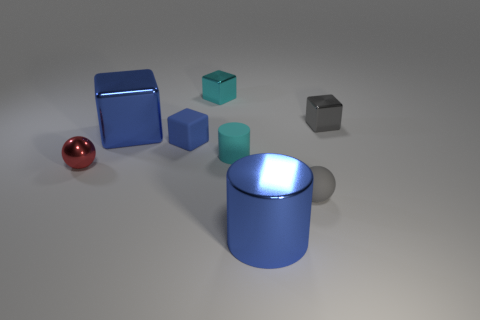The small metallic object that is the same color as the small cylinder is what shape?
Your answer should be compact. Cube. There is a rubber cube that is the same color as the large cylinder; what size is it?
Offer a terse response. Small. Is there a large cylinder made of the same material as the small blue thing?
Offer a terse response. No. There is a tiny metal object that is behind the small red ball and on the left side of the tiny cyan cylinder; what is its shape?
Make the answer very short. Cube. How many other objects are the same shape as the blue matte thing?
Your response must be concise. 3. The gray ball is what size?
Give a very brief answer. Small. How many things are big blue cubes or small objects?
Offer a terse response. 7. There is a metallic block that is on the left side of the blue matte cube; what is its size?
Offer a terse response. Large. Is there any other thing that has the same size as the red ball?
Give a very brief answer. Yes. What color is the tiny block that is in front of the cyan metallic thing and on the left side of the gray rubber sphere?
Provide a succinct answer. Blue. 